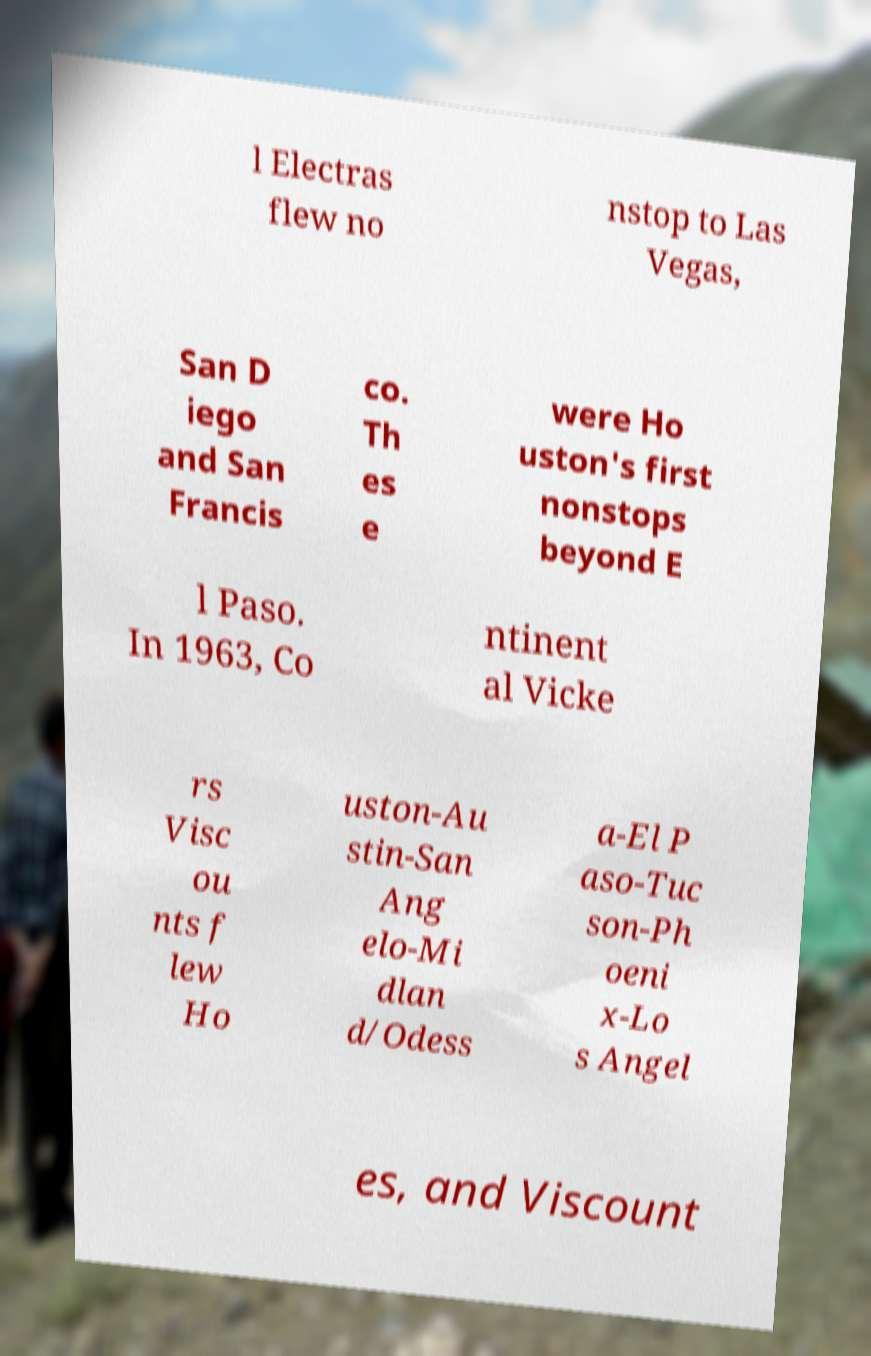What messages or text are displayed in this image? I need them in a readable, typed format. l Electras flew no nstop to Las Vegas, San D iego and San Francis co. Th es e were Ho uston's first nonstops beyond E l Paso. In 1963, Co ntinent al Vicke rs Visc ou nts f lew Ho uston-Au stin-San Ang elo-Mi dlan d/Odess a-El P aso-Tuc son-Ph oeni x-Lo s Angel es, and Viscount 